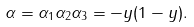Convert formula to latex. <formula><loc_0><loc_0><loc_500><loc_500>\alpha = \alpha _ { 1 } \alpha _ { 2 } \alpha _ { 3 } = - y ( 1 - y ) .</formula> 